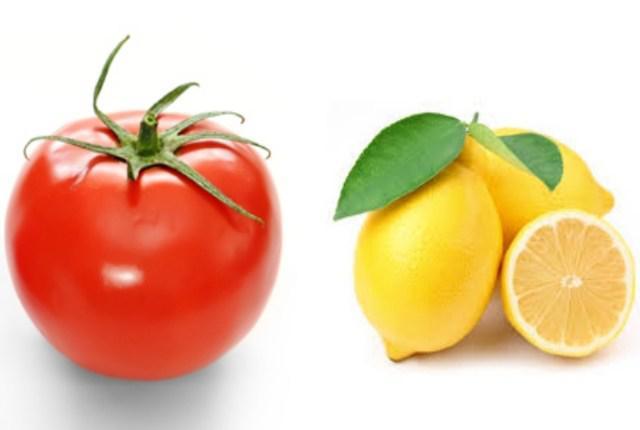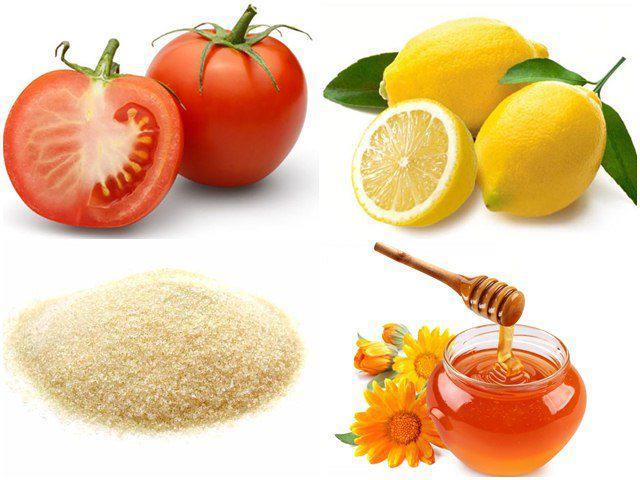The first image is the image on the left, the second image is the image on the right. Analyze the images presented: Is the assertion "There is a whole un cut tomato next to lemon and whole turmeric root which is next to the powdered turmeric" valid? Answer yes or no. No. The first image is the image on the left, the second image is the image on the right. Evaluate the accuracy of this statement regarding the images: "The left image includes at least one whole tomato and whole lemon, and exactly one bowl of grain.". Is it true? Answer yes or no. No. 